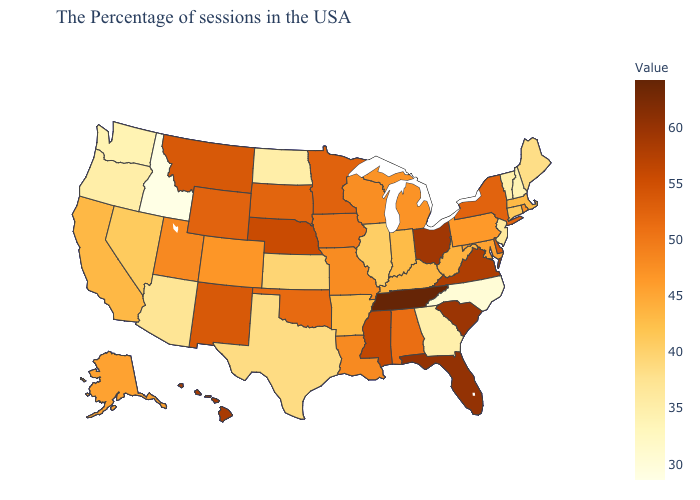Among the states that border Virginia , does North Carolina have the lowest value?
Be succinct. Yes. Does North Carolina have the lowest value in the South?
Write a very short answer. Yes. Does Idaho have the lowest value in the USA?
Write a very short answer. Yes. Is the legend a continuous bar?
Write a very short answer. Yes. 